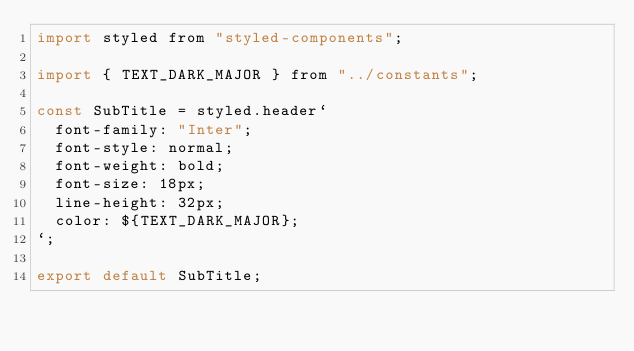Convert code to text. <code><loc_0><loc_0><loc_500><loc_500><_JavaScript_>import styled from "styled-components";

import { TEXT_DARK_MAJOR } from "../constants";

const SubTitle = styled.header`
  font-family: "Inter";
  font-style: normal;
  font-weight: bold;
  font-size: 18px;
  line-height: 32px;
  color: ${TEXT_DARK_MAJOR};
`;

export default SubTitle;
</code> 